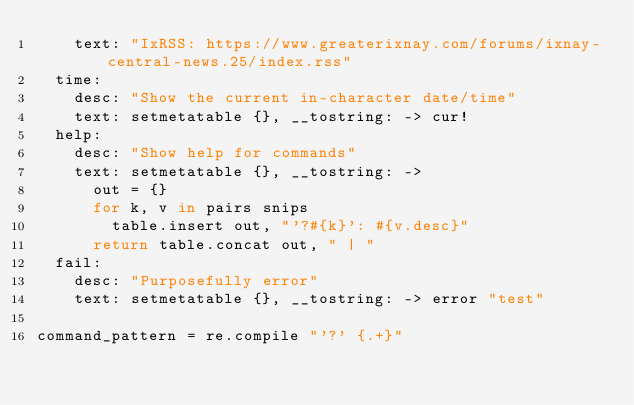Convert code to text. <code><loc_0><loc_0><loc_500><loc_500><_MoonScript_>		text: "IxRSS: https://www.greaterixnay.com/forums/ixnay-central-news.25/index.rss"
	time:
		desc: "Show the current in-character date/time"
		text: setmetatable {}, __tostring: -> cur!
	help:
		desc: "Show help for commands"
		text: setmetatable {}, __tostring: ->
			out = {}
			for k, v in pairs snips
				table.insert out, "'?#{k}': #{v.desc}"
			return table.concat out, " | "
	fail:
		desc: "Purposefully error"
		text: setmetatable {}, __tostring: -> error "test"

command_pattern = re.compile "'?' {.+}"
</code> 